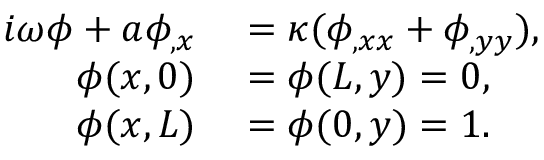<formula> <loc_0><loc_0><loc_500><loc_500>\begin{array} { r l } { i \omega \phi + a \phi _ { , x } } & = \kappa ( \phi _ { , x x } + \phi _ { , y y } ) , } \\ { \phi ( x , 0 ) } & = \phi ( L , y ) = 0 , } \\ { \phi ( x , L ) } & = \phi ( 0 , y ) = 1 . } \end{array}</formula> 